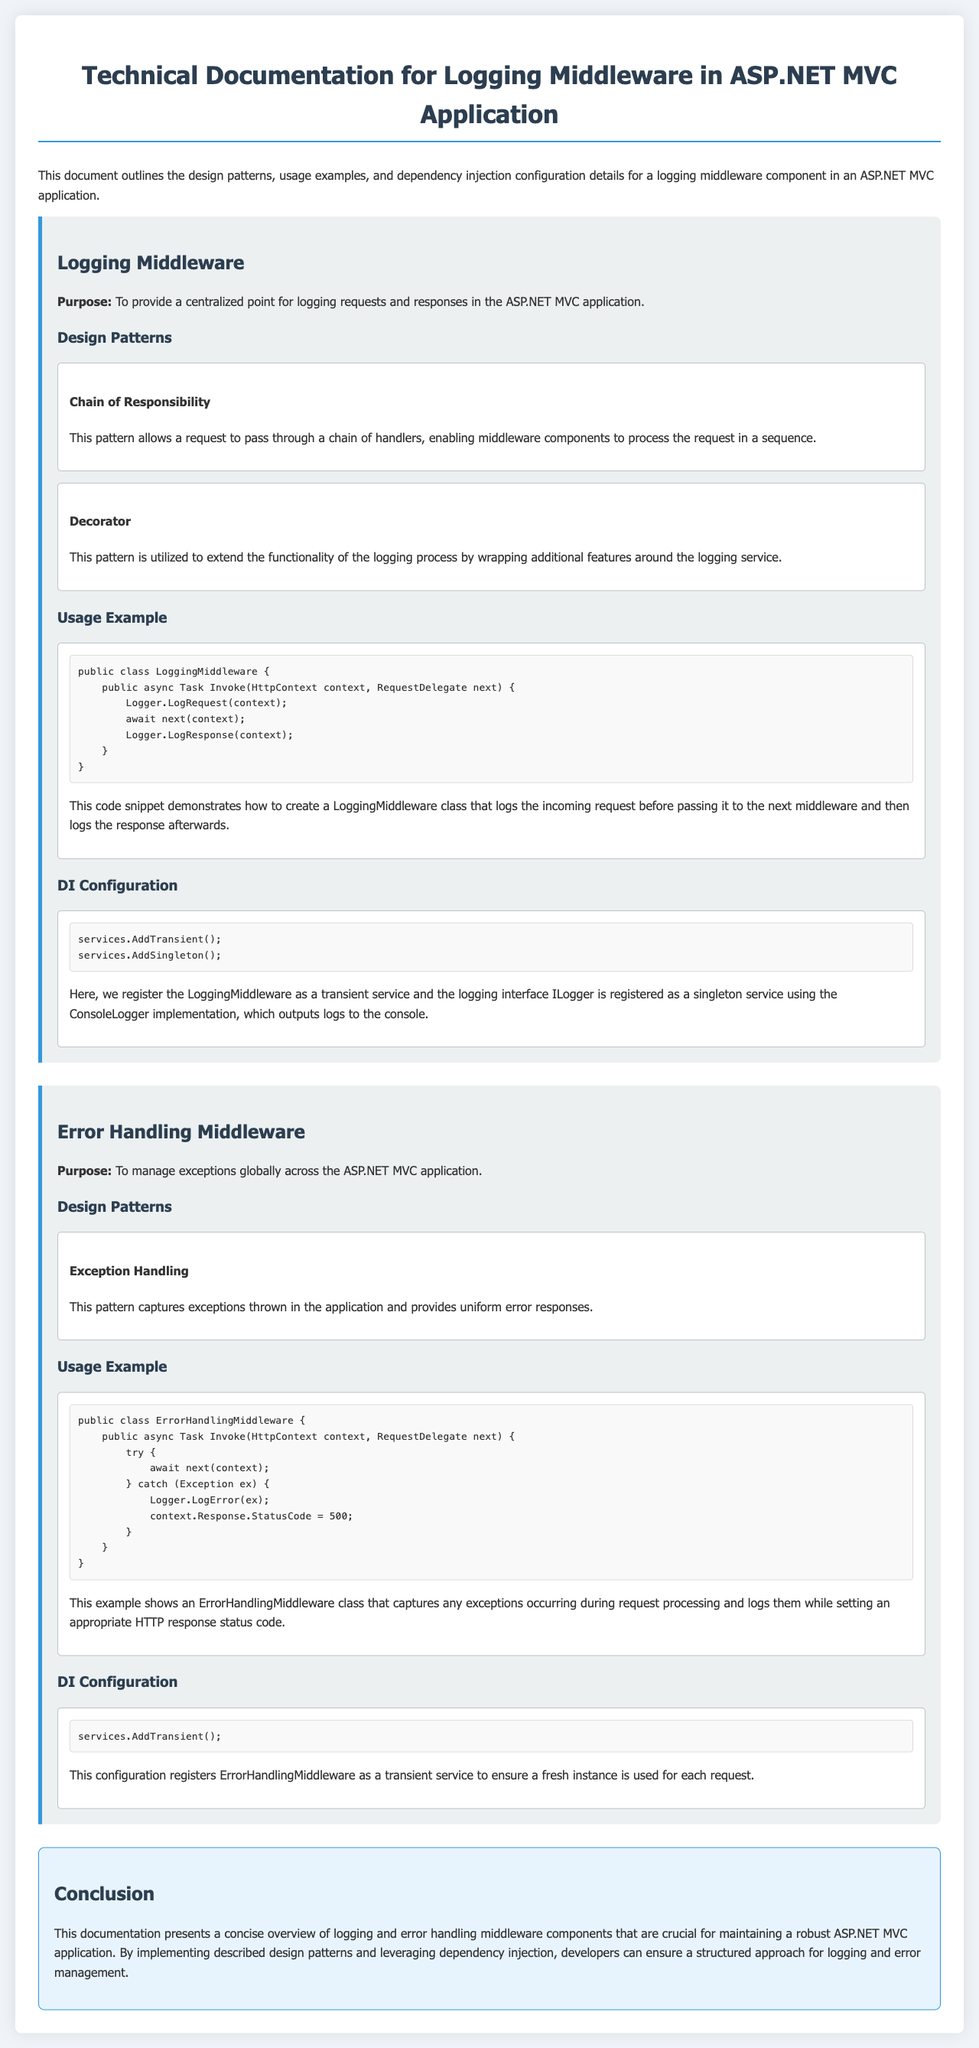What is the purpose of the Logging Middleware? The purpose is to provide a centralized point for logging requests and responses in the ASP.NET MVC application.
Answer: Centralized logging What design pattern is utilized in the Logging Middleware? The design pattern utilized is the Chain of Responsibility, which allows a request to pass through a chain of handlers.
Answer: Chain of Responsibility What is the logging service implementation mentioned in the DI configuration? The implementation mentioned is ConsoleLogger, which outputs logs to the console.
Answer: ConsoleLogger How is the ErrorHandlingMiddleware registered in the DI configuration? The ErrorHandlingMiddleware is registered as a transient service.
Answer: Transient service What status code is set in the ErrorHandlingMiddleware when an exception occurs? The status code set is 500, indicating a server error.
Answer: 500 What does the Error Handling Middleware manage? It manages exceptions globally across the ASP.NET MVC application.
Answer: Exceptions Which design pattern captures exceptions in the Error Handling Middleware? The design pattern is Exception Handling, which provides uniform error responses.
Answer: Exception Handling What is the purpose of the Error Handling Middleware? The purpose is to manage exceptions globally across the ASP.NET MVC application.
Answer: Manage exceptions How many design patterns are mentioned for the Logging Middleware? Two design patterns are mentioned for the Logging Middleware.
Answer: Two What does the Logging Middleware log before passing to the next middleware? It logs the incoming request before passing to the next middleware.
Answer: Incoming request 